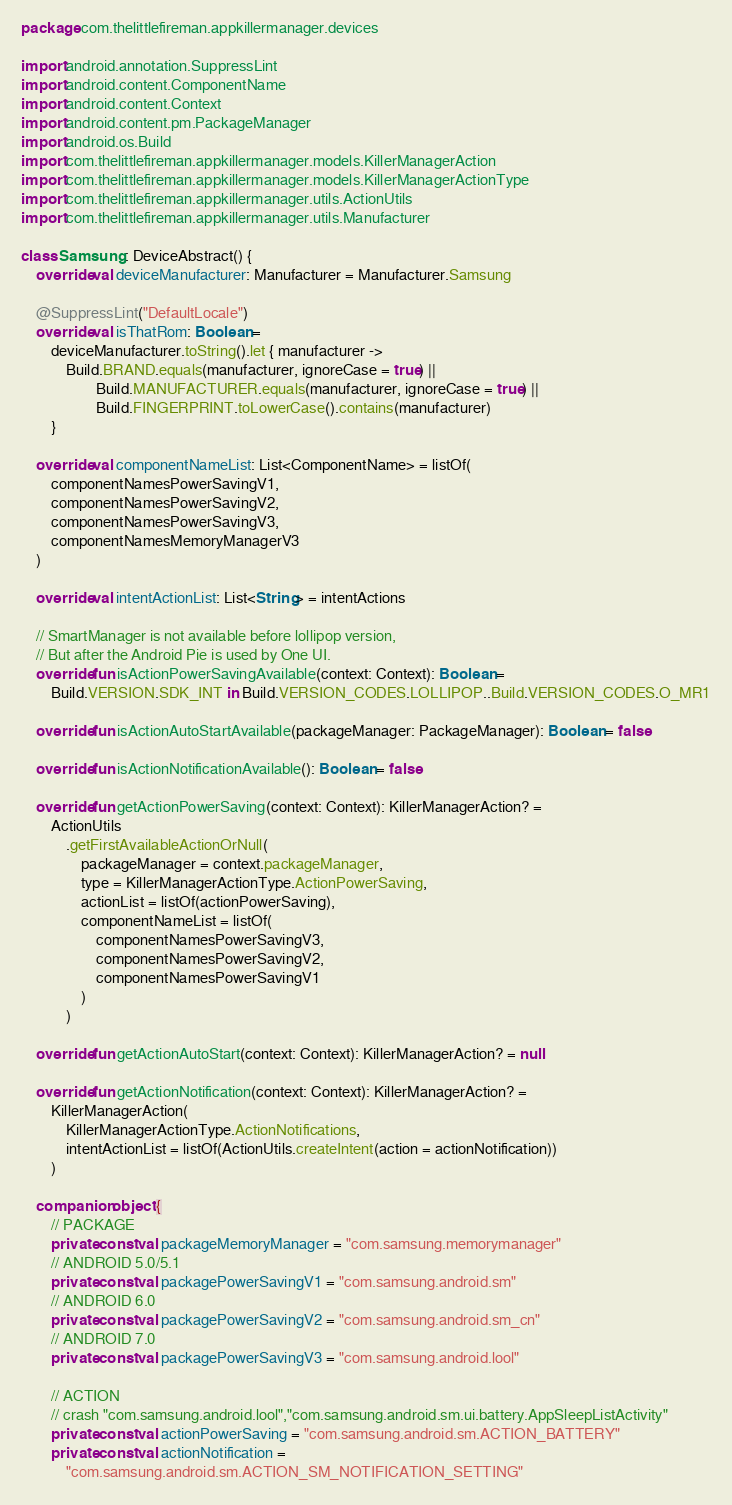<code> <loc_0><loc_0><loc_500><loc_500><_Kotlin_>package com.thelittlefireman.appkillermanager.devices

import android.annotation.SuppressLint
import android.content.ComponentName
import android.content.Context
import android.content.pm.PackageManager
import android.os.Build
import com.thelittlefireman.appkillermanager.models.KillerManagerAction
import com.thelittlefireman.appkillermanager.models.KillerManagerActionType
import com.thelittlefireman.appkillermanager.utils.ActionUtils
import com.thelittlefireman.appkillermanager.utils.Manufacturer

class Samsung : DeviceAbstract() {
    override val deviceManufacturer: Manufacturer = Manufacturer.Samsung

    @SuppressLint("DefaultLocale")
    override val isThatRom: Boolean =
        deviceManufacturer.toString().let { manufacturer ->
            Build.BRAND.equals(manufacturer, ignoreCase = true) ||
                    Build.MANUFACTURER.equals(manufacturer, ignoreCase = true) ||
                    Build.FINGERPRINT.toLowerCase().contains(manufacturer)
        }

    override val componentNameList: List<ComponentName> = listOf(
        componentNamesPowerSavingV1,
        componentNamesPowerSavingV2,
        componentNamesPowerSavingV3,
        componentNamesMemoryManagerV3
    )

    override val intentActionList: List<String> = intentActions

    // SmartManager is not available before lollipop version,
    // But after the Android Pie is used by One UI.
    override fun isActionPowerSavingAvailable(context: Context): Boolean =
        Build.VERSION.SDK_INT in Build.VERSION_CODES.LOLLIPOP..Build.VERSION_CODES.O_MR1

    override fun isActionAutoStartAvailable(packageManager: PackageManager): Boolean = false

    override fun isActionNotificationAvailable(): Boolean = false

    override fun getActionPowerSaving(context: Context): KillerManagerAction? =
        ActionUtils
            .getFirstAvailableActionOrNull(
                packageManager = context.packageManager,
                type = KillerManagerActionType.ActionPowerSaving,
                actionList = listOf(actionPowerSaving),
                componentNameList = listOf(
                    componentNamesPowerSavingV3,
                    componentNamesPowerSavingV2,
                    componentNamesPowerSavingV1
                )
            )

    override fun getActionAutoStart(context: Context): KillerManagerAction? = null

    override fun getActionNotification(context: Context): KillerManagerAction? =
        KillerManagerAction(
            KillerManagerActionType.ActionNotifications,
            intentActionList = listOf(ActionUtils.createIntent(action = actionNotification))
        )

    companion object {
        // PACKAGE
        private const val packageMemoryManager = "com.samsung.memorymanager"
        // ANDROID 5.0/5.1
        private const val packagePowerSavingV1 = "com.samsung.android.sm"
        // ANDROID 6.0
        private const val packagePowerSavingV2 = "com.samsung.android.sm_cn"
        // ANDROID 7.0
        private const val packagePowerSavingV3 = "com.samsung.android.lool"

        // ACTION
        // crash "com.samsung.android.lool","com.samsung.android.sm.ui.battery.AppSleepListActivity"
        private const val actionPowerSaving = "com.samsung.android.sm.ACTION_BATTERY"
        private const val actionNotification =
            "com.samsung.android.sm.ACTION_SM_NOTIFICATION_SETTING"</code> 